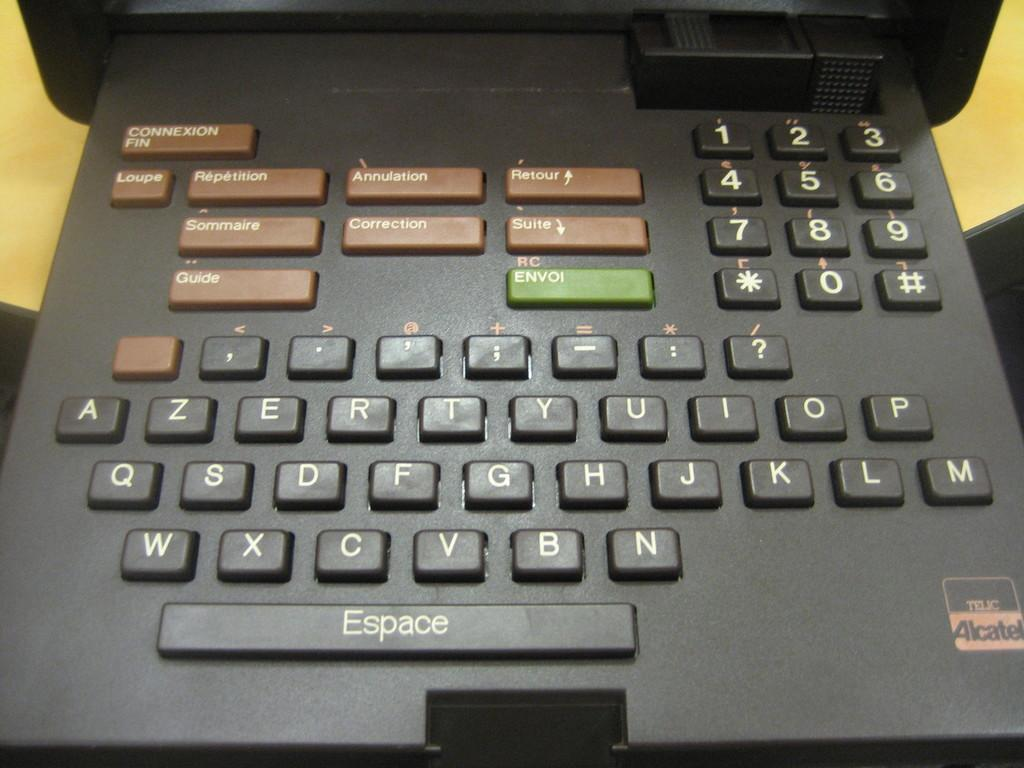<image>
Create a compact narrative representing the image presented. A small electronic keyboard has a space bar labeled Espace. 